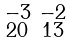<formula> <loc_0><loc_0><loc_500><loc_500>\begin{smallmatrix} - 3 & - 2 \\ 2 0 & 1 3 \end{smallmatrix}</formula> 